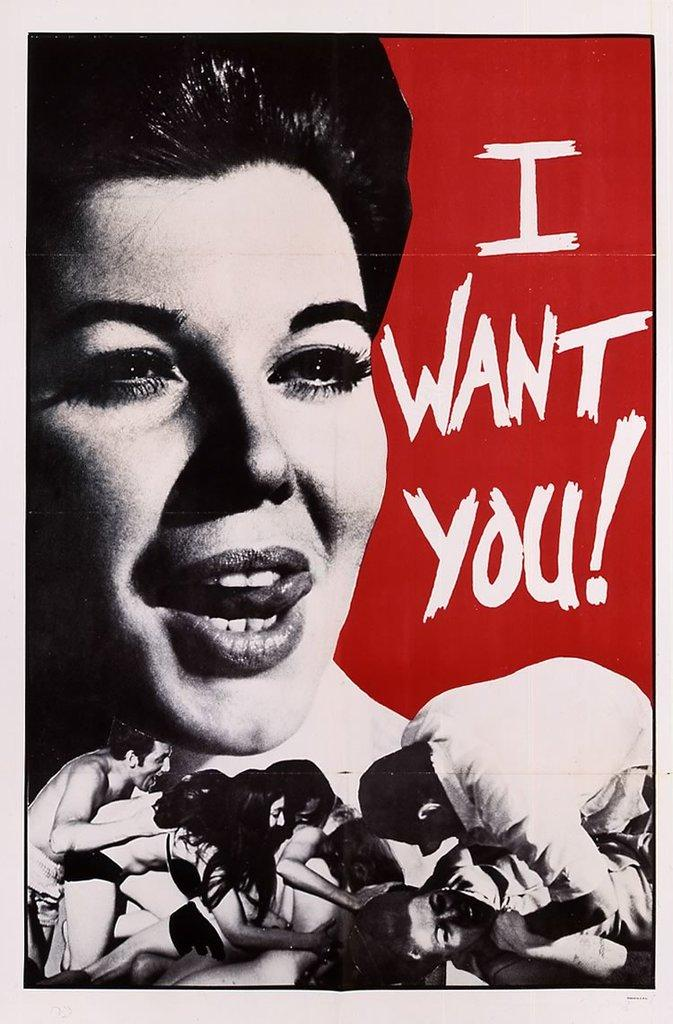<image>
Give a short and clear explanation of the subsequent image. Sexually explicit photo cover with the words "I Want You!" on the right. 